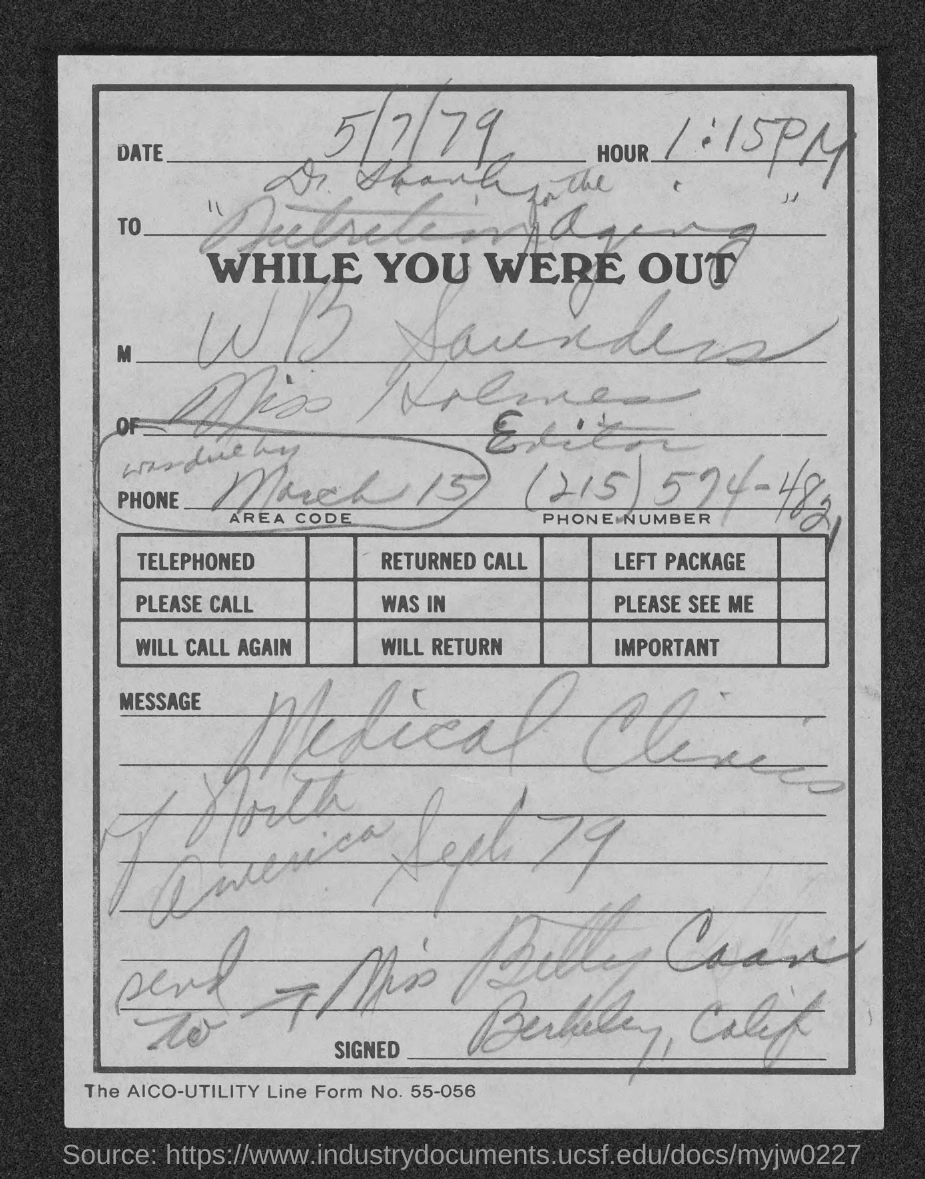What is the issued date of this document?
Keep it short and to the point. 5/7/79. What is the time/Hour given in the document?
Make the answer very short. 1:15 PM. What is the phone no mentioned in this document?
Provide a succinct answer. (215) 574-4821. 